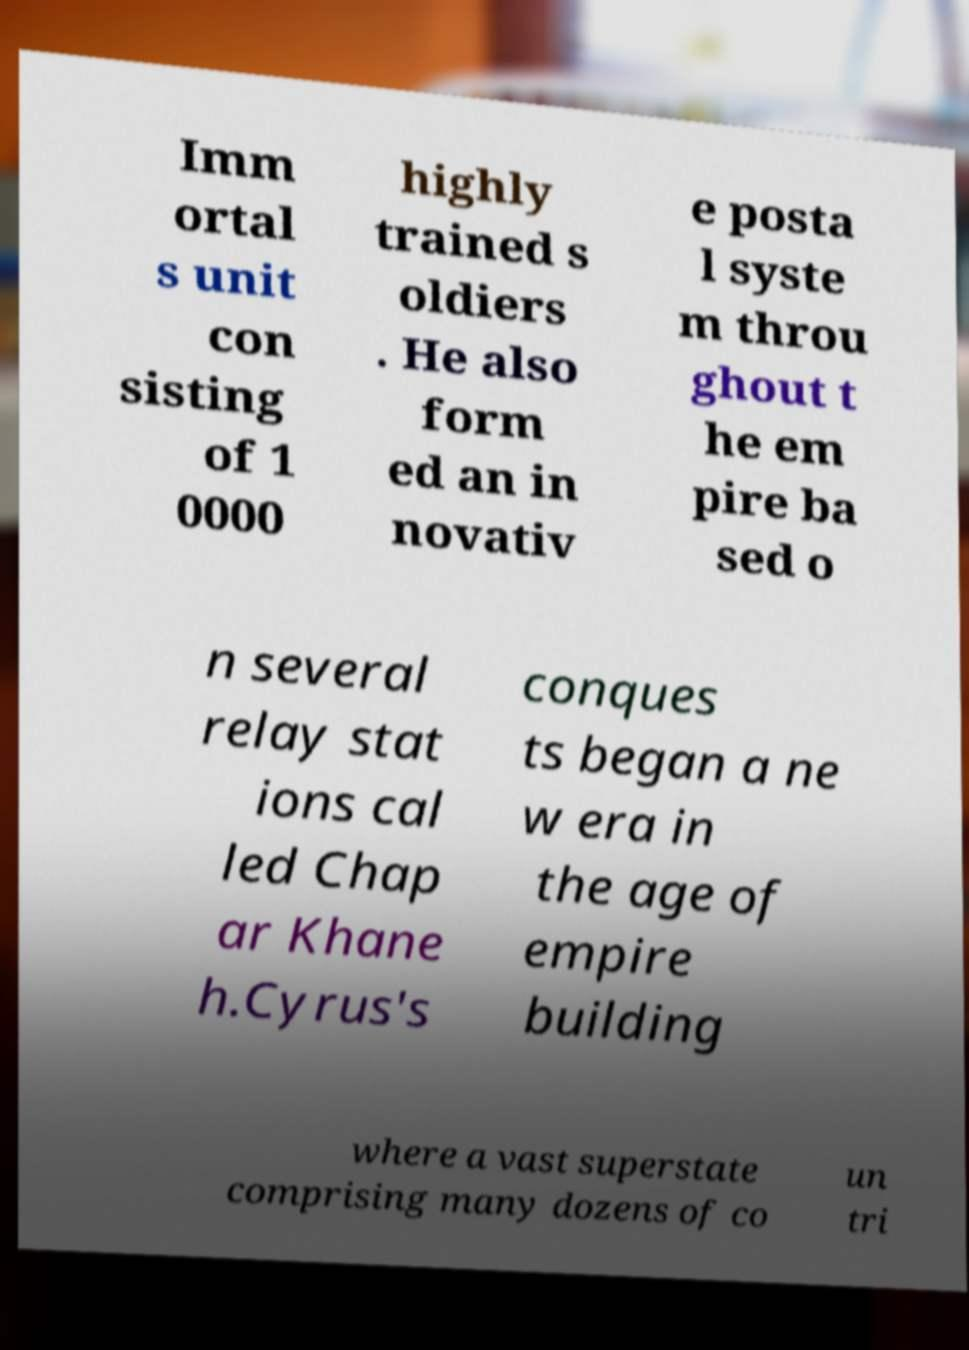Can you read and provide the text displayed in the image?This photo seems to have some interesting text. Can you extract and type it out for me? Imm ortal s unit con sisting of 1 0000 highly trained s oldiers . He also form ed an in novativ e posta l syste m throu ghout t he em pire ba sed o n several relay stat ions cal led Chap ar Khane h.Cyrus's conques ts began a ne w era in the age of empire building where a vast superstate comprising many dozens of co un tri 